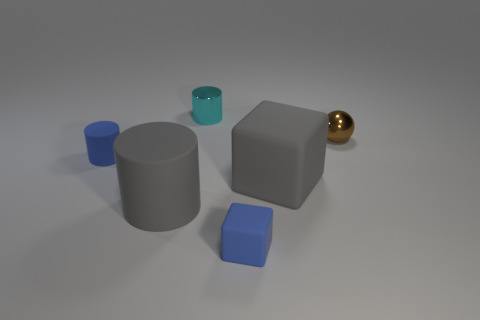Is there any other thing that has the same shape as the tiny brown thing?
Your answer should be very brief. No. Is there anything else that is the same size as the gray matte block?
Offer a very short reply. Yes. What color is the big cylinder that is the same material as the large cube?
Give a very brief answer. Gray. There is a metal thing left of the shiny sphere; what is its color?
Your response must be concise. Cyan. What number of metallic cylinders are the same color as the small sphere?
Your answer should be compact. 0. Is the number of tiny blue blocks that are behind the small blue matte cube less than the number of tiny things on the right side of the small cyan metal thing?
Keep it short and to the point. Yes. How many large gray cylinders are on the right side of the big matte block?
Offer a terse response. 0. Are there any gray cubes that have the same material as the tiny sphere?
Provide a short and direct response. No. Are there more tiny spheres in front of the small ball than small blue cylinders that are right of the cyan thing?
Offer a very short reply. No. The blue rubber cylinder is what size?
Offer a very short reply. Small. 